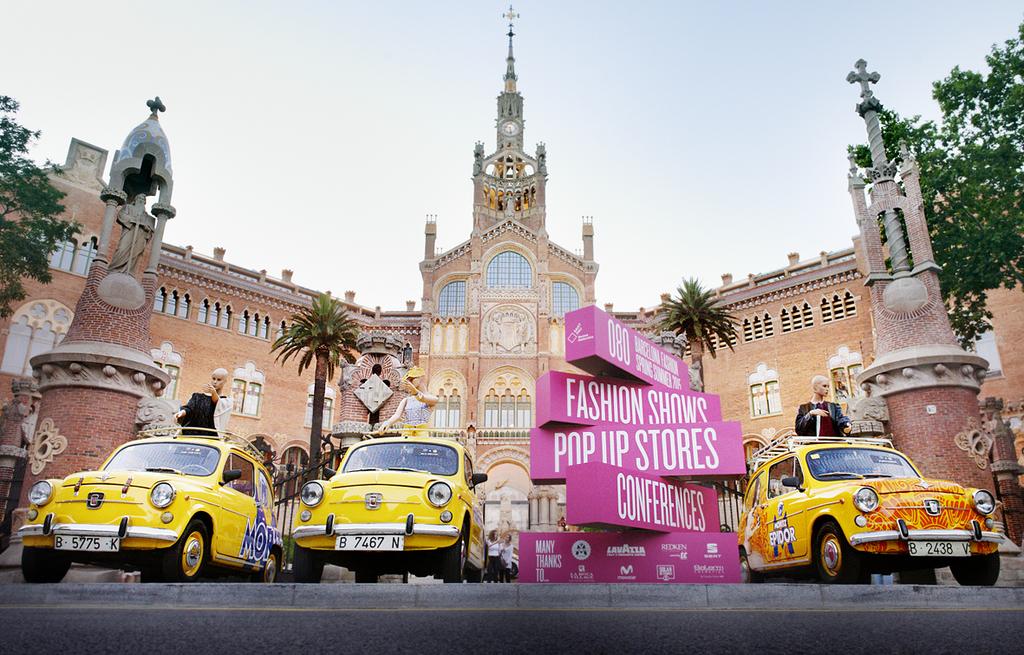What items are featured here?
Provide a succinct answer. Answering does not require reading text in the image. What is the license plate number of the car in the middle?
Keep it short and to the point. B 7467 n. 